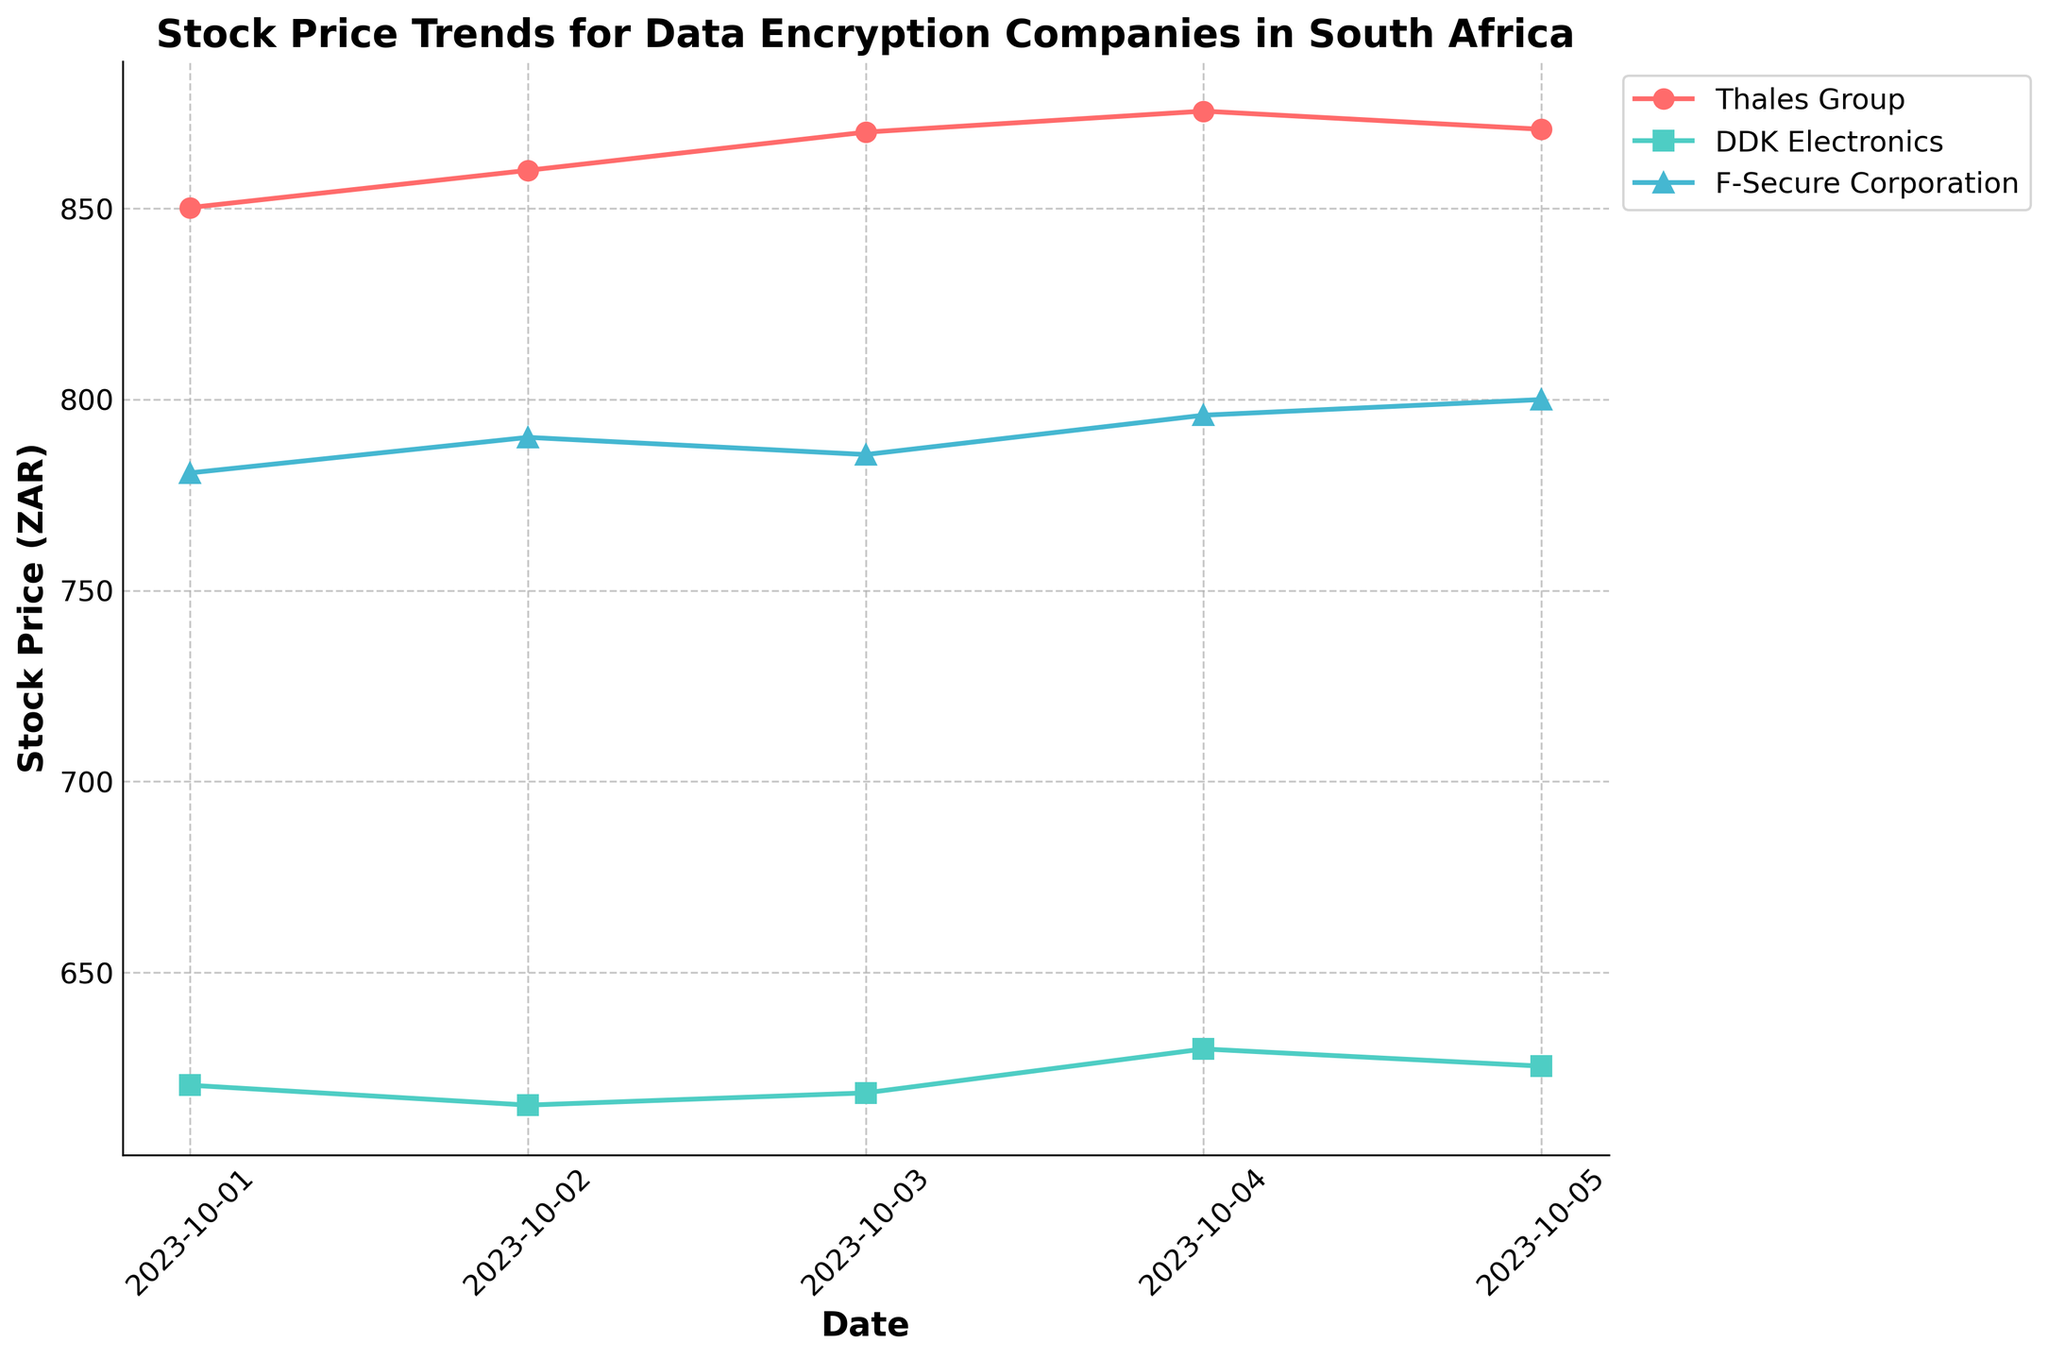What is the title of the plot? The title of the plot is typically found near the top center of the figure in bold text and, in this case, reads "Stock Price Trends for Data Encryption Companies in South Africa".
Answer: Stock Price Trends for Data Encryption Companies in South Africa What are the labels of the x-axis and y-axis? The labels are usually found on each axis. The x-axis label reads "Date", and the y-axis label reads "Stock Price (ZAR)".
Answer: Date; Stock Price (ZAR) Which company saw the highest stock price on October 2, 2023? By looking at the data points for each company on the x-coordinate for October 2, 2023, we observe that the highest stock price is for Thales Group.
Answer: Thales Group On which date did DDK Electronics have its highest stock price? Trace the line corresponding to DDK Electronics and compare the stock prices across the dates to find the maximum. The highest price is on October 4, 2023.
Answer: October 4, 2023 What is the trend of stock prices for Thales Group from October 1, 2023 to October 5, 2023? Analyze the line representing Thales Group from the starting to the ending date. The stock price consistently increases from October 1 to October 4 and then decreases slightly on October 5.
Answer: Generally increasing Between Thales Group and F-Secure Corporation, which company had a higher stock price on October 1, 2023? Compare the data points for Thales Group and F-Secure Corporation on October 1. Thales Group had a stock price of 850.25 ZAR, while F-Secure Corporation had 780.80 ZAR.
Answer: Thales Group What is the range of DDK Electronics' stock prices over the period shown? Identify the minimum and maximum stock prices for DDK Electronics and calculate the range (maximum - minimum). The prices are between 615.30 and 630.00 ZAR, so the range is 630.00 - 615.30 = 14.70 ZAR.
Answer: 14.70 ZAR How does the volatility of F-Secure Corporation compare to that of Thales Group on October 4, 2023? Look at the volatility values for both companies on October 4. F-Secure Corporation has a volatility of 0.20, and Thales Group has a volatility of 0.22. Thus, Thales Group had higher volatility.
Answer: Thales Group had higher volatility On which date did F-Secure Corporation experience its highest volatility and what was it? Track the individual volatility values for F-Secure Corporation shown along the timeline and identify the maximum value. The highest volatility, 0.25, occurred on October 5, 2023.
Answer: October 5, 2023; 0.25 What is the average stock price of Thales Group over the period covered in the plot? Sum up the stock prices of Thales Group (850.25, 860.00, 870.00, 875.50, 870.75) and divide by the number of data points (5). The sum is 4326.50, so the average is 4326.50/5 = 865.30 ZAR.
Answer: 865.30 ZAR 